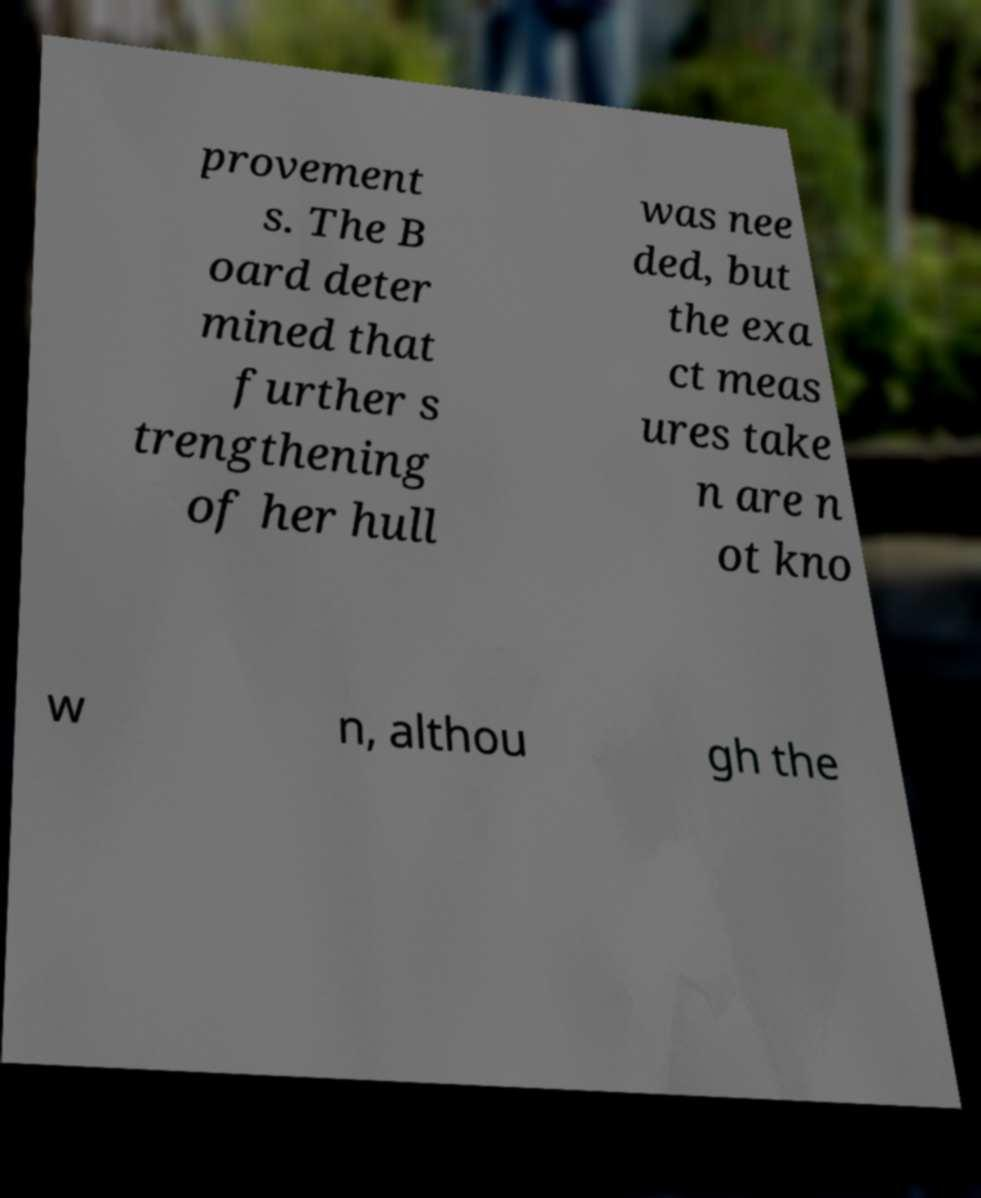Please read and relay the text visible in this image. What does it say? provement s. The B oard deter mined that further s trengthening of her hull was nee ded, but the exa ct meas ures take n are n ot kno w n, althou gh the 